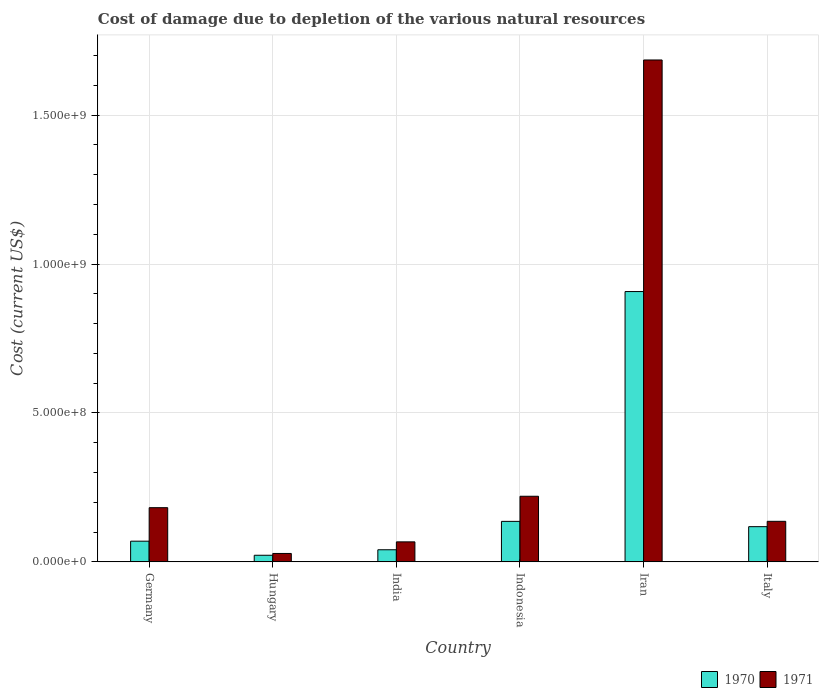How many different coloured bars are there?
Your answer should be compact. 2. Are the number of bars per tick equal to the number of legend labels?
Make the answer very short. Yes. How many bars are there on the 2nd tick from the left?
Provide a short and direct response. 2. In how many cases, is the number of bars for a given country not equal to the number of legend labels?
Your answer should be compact. 0. What is the cost of damage caused due to the depletion of various natural resources in 1971 in Iran?
Offer a very short reply. 1.69e+09. Across all countries, what is the maximum cost of damage caused due to the depletion of various natural resources in 1970?
Your answer should be compact. 9.08e+08. Across all countries, what is the minimum cost of damage caused due to the depletion of various natural resources in 1971?
Offer a very short reply. 2.83e+07. In which country was the cost of damage caused due to the depletion of various natural resources in 1970 maximum?
Offer a very short reply. Iran. In which country was the cost of damage caused due to the depletion of various natural resources in 1970 minimum?
Ensure brevity in your answer.  Hungary. What is the total cost of damage caused due to the depletion of various natural resources in 1971 in the graph?
Offer a terse response. 2.32e+09. What is the difference between the cost of damage caused due to the depletion of various natural resources in 1971 in India and that in Iran?
Make the answer very short. -1.62e+09. What is the difference between the cost of damage caused due to the depletion of various natural resources in 1970 in Germany and the cost of damage caused due to the depletion of various natural resources in 1971 in Italy?
Your response must be concise. -6.67e+07. What is the average cost of damage caused due to the depletion of various natural resources in 1970 per country?
Offer a terse response. 2.16e+08. What is the difference between the cost of damage caused due to the depletion of various natural resources of/in 1970 and cost of damage caused due to the depletion of various natural resources of/in 1971 in India?
Offer a very short reply. -2.65e+07. What is the ratio of the cost of damage caused due to the depletion of various natural resources in 1970 in Hungary to that in Indonesia?
Ensure brevity in your answer.  0.16. Is the cost of damage caused due to the depletion of various natural resources in 1971 in Hungary less than that in India?
Your answer should be compact. Yes. What is the difference between the highest and the second highest cost of damage caused due to the depletion of various natural resources in 1971?
Provide a succinct answer. -1.46e+09. What is the difference between the highest and the lowest cost of damage caused due to the depletion of various natural resources in 1970?
Your answer should be very brief. 8.85e+08. In how many countries, is the cost of damage caused due to the depletion of various natural resources in 1970 greater than the average cost of damage caused due to the depletion of various natural resources in 1970 taken over all countries?
Give a very brief answer. 1. Is the sum of the cost of damage caused due to the depletion of various natural resources in 1970 in Germany and Indonesia greater than the maximum cost of damage caused due to the depletion of various natural resources in 1971 across all countries?
Your answer should be very brief. No. What does the 1st bar from the left in Hungary represents?
Offer a terse response. 1970. Are all the bars in the graph horizontal?
Offer a terse response. No. How many countries are there in the graph?
Your answer should be compact. 6. What is the difference between two consecutive major ticks on the Y-axis?
Provide a succinct answer. 5.00e+08. Does the graph contain any zero values?
Offer a very short reply. No. Where does the legend appear in the graph?
Offer a terse response. Bottom right. What is the title of the graph?
Provide a short and direct response. Cost of damage due to depletion of the various natural resources. Does "1960" appear as one of the legend labels in the graph?
Your response must be concise. No. What is the label or title of the X-axis?
Offer a very short reply. Country. What is the label or title of the Y-axis?
Your answer should be compact. Cost (current US$). What is the Cost (current US$) of 1970 in Germany?
Provide a succinct answer. 6.95e+07. What is the Cost (current US$) of 1971 in Germany?
Make the answer very short. 1.82e+08. What is the Cost (current US$) in 1970 in Hungary?
Keep it short and to the point. 2.22e+07. What is the Cost (current US$) in 1971 in Hungary?
Ensure brevity in your answer.  2.83e+07. What is the Cost (current US$) of 1970 in India?
Provide a succinct answer. 4.07e+07. What is the Cost (current US$) in 1971 in India?
Your answer should be very brief. 6.72e+07. What is the Cost (current US$) in 1970 in Indonesia?
Keep it short and to the point. 1.36e+08. What is the Cost (current US$) of 1971 in Indonesia?
Give a very brief answer. 2.20e+08. What is the Cost (current US$) of 1970 in Iran?
Provide a succinct answer. 9.08e+08. What is the Cost (current US$) in 1971 in Iran?
Your answer should be compact. 1.69e+09. What is the Cost (current US$) in 1970 in Italy?
Your answer should be very brief. 1.18e+08. What is the Cost (current US$) of 1971 in Italy?
Make the answer very short. 1.36e+08. Across all countries, what is the maximum Cost (current US$) of 1970?
Provide a succinct answer. 9.08e+08. Across all countries, what is the maximum Cost (current US$) of 1971?
Provide a succinct answer. 1.69e+09. Across all countries, what is the minimum Cost (current US$) of 1970?
Make the answer very short. 2.22e+07. Across all countries, what is the minimum Cost (current US$) in 1971?
Your answer should be compact. 2.83e+07. What is the total Cost (current US$) of 1970 in the graph?
Your answer should be compact. 1.29e+09. What is the total Cost (current US$) in 1971 in the graph?
Make the answer very short. 2.32e+09. What is the difference between the Cost (current US$) of 1970 in Germany and that in Hungary?
Your response must be concise. 4.72e+07. What is the difference between the Cost (current US$) in 1971 in Germany and that in Hungary?
Offer a terse response. 1.54e+08. What is the difference between the Cost (current US$) of 1970 in Germany and that in India?
Your answer should be very brief. 2.88e+07. What is the difference between the Cost (current US$) of 1971 in Germany and that in India?
Offer a terse response. 1.15e+08. What is the difference between the Cost (current US$) of 1970 in Germany and that in Indonesia?
Provide a succinct answer. -6.65e+07. What is the difference between the Cost (current US$) in 1971 in Germany and that in Indonesia?
Provide a succinct answer. -3.83e+07. What is the difference between the Cost (current US$) in 1970 in Germany and that in Iran?
Ensure brevity in your answer.  -8.38e+08. What is the difference between the Cost (current US$) of 1971 in Germany and that in Iran?
Offer a very short reply. -1.50e+09. What is the difference between the Cost (current US$) in 1970 in Germany and that in Italy?
Ensure brevity in your answer.  -4.87e+07. What is the difference between the Cost (current US$) in 1971 in Germany and that in Italy?
Make the answer very short. 4.58e+07. What is the difference between the Cost (current US$) of 1970 in Hungary and that in India?
Offer a very short reply. -1.85e+07. What is the difference between the Cost (current US$) of 1971 in Hungary and that in India?
Provide a short and direct response. -3.89e+07. What is the difference between the Cost (current US$) of 1970 in Hungary and that in Indonesia?
Provide a succinct answer. -1.14e+08. What is the difference between the Cost (current US$) of 1971 in Hungary and that in Indonesia?
Offer a terse response. -1.92e+08. What is the difference between the Cost (current US$) of 1970 in Hungary and that in Iran?
Keep it short and to the point. -8.85e+08. What is the difference between the Cost (current US$) of 1971 in Hungary and that in Iran?
Give a very brief answer. -1.66e+09. What is the difference between the Cost (current US$) in 1970 in Hungary and that in Italy?
Give a very brief answer. -9.60e+07. What is the difference between the Cost (current US$) of 1971 in Hungary and that in Italy?
Offer a terse response. -1.08e+08. What is the difference between the Cost (current US$) in 1970 in India and that in Indonesia?
Offer a terse response. -9.53e+07. What is the difference between the Cost (current US$) of 1971 in India and that in Indonesia?
Your answer should be very brief. -1.53e+08. What is the difference between the Cost (current US$) of 1970 in India and that in Iran?
Your response must be concise. -8.67e+08. What is the difference between the Cost (current US$) in 1971 in India and that in Iran?
Give a very brief answer. -1.62e+09. What is the difference between the Cost (current US$) in 1970 in India and that in Italy?
Your answer should be very brief. -7.75e+07. What is the difference between the Cost (current US$) of 1971 in India and that in Italy?
Your answer should be compact. -6.90e+07. What is the difference between the Cost (current US$) of 1970 in Indonesia and that in Iran?
Keep it short and to the point. -7.72e+08. What is the difference between the Cost (current US$) in 1971 in Indonesia and that in Iran?
Make the answer very short. -1.46e+09. What is the difference between the Cost (current US$) in 1970 in Indonesia and that in Italy?
Offer a terse response. 1.78e+07. What is the difference between the Cost (current US$) in 1971 in Indonesia and that in Italy?
Your answer should be very brief. 8.41e+07. What is the difference between the Cost (current US$) in 1970 in Iran and that in Italy?
Give a very brief answer. 7.89e+08. What is the difference between the Cost (current US$) of 1971 in Iran and that in Italy?
Keep it short and to the point. 1.55e+09. What is the difference between the Cost (current US$) of 1970 in Germany and the Cost (current US$) of 1971 in Hungary?
Your response must be concise. 4.12e+07. What is the difference between the Cost (current US$) of 1970 in Germany and the Cost (current US$) of 1971 in India?
Your answer should be compact. 2.27e+06. What is the difference between the Cost (current US$) in 1970 in Germany and the Cost (current US$) in 1971 in Indonesia?
Your answer should be compact. -1.51e+08. What is the difference between the Cost (current US$) in 1970 in Germany and the Cost (current US$) in 1971 in Iran?
Offer a terse response. -1.62e+09. What is the difference between the Cost (current US$) in 1970 in Germany and the Cost (current US$) in 1971 in Italy?
Make the answer very short. -6.67e+07. What is the difference between the Cost (current US$) in 1970 in Hungary and the Cost (current US$) in 1971 in India?
Your response must be concise. -4.50e+07. What is the difference between the Cost (current US$) of 1970 in Hungary and the Cost (current US$) of 1971 in Indonesia?
Ensure brevity in your answer.  -1.98e+08. What is the difference between the Cost (current US$) of 1970 in Hungary and the Cost (current US$) of 1971 in Iran?
Keep it short and to the point. -1.66e+09. What is the difference between the Cost (current US$) in 1970 in Hungary and the Cost (current US$) in 1971 in Italy?
Give a very brief answer. -1.14e+08. What is the difference between the Cost (current US$) in 1970 in India and the Cost (current US$) in 1971 in Indonesia?
Your response must be concise. -1.80e+08. What is the difference between the Cost (current US$) in 1970 in India and the Cost (current US$) in 1971 in Iran?
Provide a short and direct response. -1.64e+09. What is the difference between the Cost (current US$) of 1970 in India and the Cost (current US$) of 1971 in Italy?
Make the answer very short. -9.55e+07. What is the difference between the Cost (current US$) in 1970 in Indonesia and the Cost (current US$) in 1971 in Iran?
Your answer should be very brief. -1.55e+09. What is the difference between the Cost (current US$) in 1970 in Indonesia and the Cost (current US$) in 1971 in Italy?
Keep it short and to the point. -1.72e+05. What is the difference between the Cost (current US$) in 1970 in Iran and the Cost (current US$) in 1971 in Italy?
Keep it short and to the point. 7.71e+08. What is the average Cost (current US$) in 1970 per country?
Ensure brevity in your answer.  2.16e+08. What is the average Cost (current US$) in 1971 per country?
Your answer should be very brief. 3.87e+08. What is the difference between the Cost (current US$) in 1970 and Cost (current US$) in 1971 in Germany?
Offer a terse response. -1.13e+08. What is the difference between the Cost (current US$) in 1970 and Cost (current US$) in 1971 in Hungary?
Your answer should be compact. -6.02e+06. What is the difference between the Cost (current US$) of 1970 and Cost (current US$) of 1971 in India?
Your response must be concise. -2.65e+07. What is the difference between the Cost (current US$) in 1970 and Cost (current US$) in 1971 in Indonesia?
Make the answer very short. -8.43e+07. What is the difference between the Cost (current US$) in 1970 and Cost (current US$) in 1971 in Iran?
Your response must be concise. -7.78e+08. What is the difference between the Cost (current US$) in 1970 and Cost (current US$) in 1971 in Italy?
Keep it short and to the point. -1.80e+07. What is the ratio of the Cost (current US$) of 1970 in Germany to that in Hungary?
Give a very brief answer. 3.12. What is the ratio of the Cost (current US$) of 1971 in Germany to that in Hungary?
Your answer should be compact. 6.44. What is the ratio of the Cost (current US$) in 1970 in Germany to that in India?
Your answer should be very brief. 1.71. What is the ratio of the Cost (current US$) of 1971 in Germany to that in India?
Offer a very short reply. 2.71. What is the ratio of the Cost (current US$) of 1970 in Germany to that in Indonesia?
Ensure brevity in your answer.  0.51. What is the ratio of the Cost (current US$) in 1971 in Germany to that in Indonesia?
Your answer should be very brief. 0.83. What is the ratio of the Cost (current US$) in 1970 in Germany to that in Iran?
Your answer should be very brief. 0.08. What is the ratio of the Cost (current US$) in 1971 in Germany to that in Iran?
Offer a terse response. 0.11. What is the ratio of the Cost (current US$) of 1970 in Germany to that in Italy?
Provide a succinct answer. 0.59. What is the ratio of the Cost (current US$) of 1971 in Germany to that in Italy?
Ensure brevity in your answer.  1.34. What is the ratio of the Cost (current US$) of 1970 in Hungary to that in India?
Provide a short and direct response. 0.55. What is the ratio of the Cost (current US$) of 1971 in Hungary to that in India?
Your answer should be very brief. 0.42. What is the ratio of the Cost (current US$) of 1970 in Hungary to that in Indonesia?
Offer a terse response. 0.16. What is the ratio of the Cost (current US$) of 1971 in Hungary to that in Indonesia?
Your answer should be very brief. 0.13. What is the ratio of the Cost (current US$) of 1970 in Hungary to that in Iran?
Provide a short and direct response. 0.02. What is the ratio of the Cost (current US$) of 1971 in Hungary to that in Iran?
Your response must be concise. 0.02. What is the ratio of the Cost (current US$) in 1970 in Hungary to that in Italy?
Offer a terse response. 0.19. What is the ratio of the Cost (current US$) of 1971 in Hungary to that in Italy?
Give a very brief answer. 0.21. What is the ratio of the Cost (current US$) in 1970 in India to that in Indonesia?
Make the answer very short. 0.3. What is the ratio of the Cost (current US$) in 1971 in India to that in Indonesia?
Keep it short and to the point. 0.3. What is the ratio of the Cost (current US$) of 1970 in India to that in Iran?
Make the answer very short. 0.04. What is the ratio of the Cost (current US$) of 1971 in India to that in Iran?
Keep it short and to the point. 0.04. What is the ratio of the Cost (current US$) in 1970 in India to that in Italy?
Make the answer very short. 0.34. What is the ratio of the Cost (current US$) in 1971 in India to that in Italy?
Ensure brevity in your answer.  0.49. What is the ratio of the Cost (current US$) in 1970 in Indonesia to that in Iran?
Offer a terse response. 0.15. What is the ratio of the Cost (current US$) of 1971 in Indonesia to that in Iran?
Make the answer very short. 0.13. What is the ratio of the Cost (current US$) in 1970 in Indonesia to that in Italy?
Keep it short and to the point. 1.15. What is the ratio of the Cost (current US$) in 1971 in Indonesia to that in Italy?
Your response must be concise. 1.62. What is the ratio of the Cost (current US$) in 1970 in Iran to that in Italy?
Keep it short and to the point. 7.68. What is the ratio of the Cost (current US$) of 1971 in Iran to that in Italy?
Ensure brevity in your answer.  12.37. What is the difference between the highest and the second highest Cost (current US$) of 1970?
Your response must be concise. 7.72e+08. What is the difference between the highest and the second highest Cost (current US$) in 1971?
Your response must be concise. 1.46e+09. What is the difference between the highest and the lowest Cost (current US$) in 1970?
Your response must be concise. 8.85e+08. What is the difference between the highest and the lowest Cost (current US$) in 1971?
Offer a very short reply. 1.66e+09. 